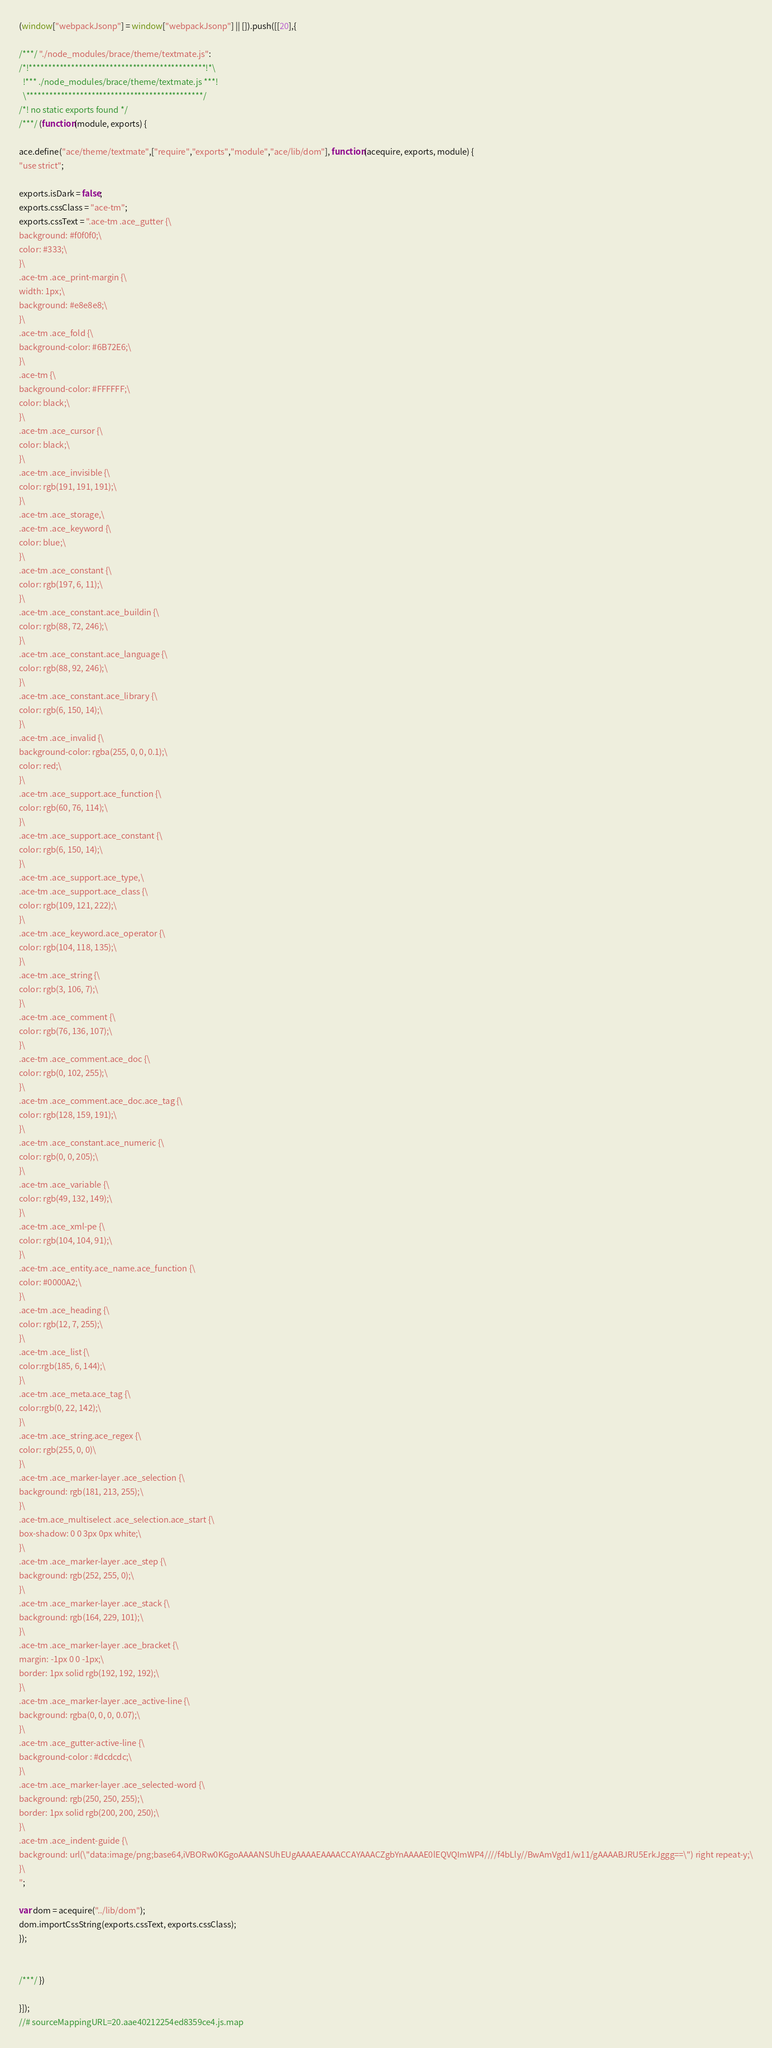Convert code to text. <code><loc_0><loc_0><loc_500><loc_500><_JavaScript_>(window["webpackJsonp"] = window["webpackJsonp"] || []).push([[20],{

/***/ "./node_modules/brace/theme/textmate.js":
/*!**********************************************!*\
  !*** ./node_modules/brace/theme/textmate.js ***!
  \**********************************************/
/*! no static exports found */
/***/ (function(module, exports) {

ace.define("ace/theme/textmate",["require","exports","module","ace/lib/dom"], function(acequire, exports, module) {
"use strict";

exports.isDark = false;
exports.cssClass = "ace-tm";
exports.cssText = ".ace-tm .ace_gutter {\
background: #f0f0f0;\
color: #333;\
}\
.ace-tm .ace_print-margin {\
width: 1px;\
background: #e8e8e8;\
}\
.ace-tm .ace_fold {\
background-color: #6B72E6;\
}\
.ace-tm {\
background-color: #FFFFFF;\
color: black;\
}\
.ace-tm .ace_cursor {\
color: black;\
}\
.ace-tm .ace_invisible {\
color: rgb(191, 191, 191);\
}\
.ace-tm .ace_storage,\
.ace-tm .ace_keyword {\
color: blue;\
}\
.ace-tm .ace_constant {\
color: rgb(197, 6, 11);\
}\
.ace-tm .ace_constant.ace_buildin {\
color: rgb(88, 72, 246);\
}\
.ace-tm .ace_constant.ace_language {\
color: rgb(88, 92, 246);\
}\
.ace-tm .ace_constant.ace_library {\
color: rgb(6, 150, 14);\
}\
.ace-tm .ace_invalid {\
background-color: rgba(255, 0, 0, 0.1);\
color: red;\
}\
.ace-tm .ace_support.ace_function {\
color: rgb(60, 76, 114);\
}\
.ace-tm .ace_support.ace_constant {\
color: rgb(6, 150, 14);\
}\
.ace-tm .ace_support.ace_type,\
.ace-tm .ace_support.ace_class {\
color: rgb(109, 121, 222);\
}\
.ace-tm .ace_keyword.ace_operator {\
color: rgb(104, 118, 135);\
}\
.ace-tm .ace_string {\
color: rgb(3, 106, 7);\
}\
.ace-tm .ace_comment {\
color: rgb(76, 136, 107);\
}\
.ace-tm .ace_comment.ace_doc {\
color: rgb(0, 102, 255);\
}\
.ace-tm .ace_comment.ace_doc.ace_tag {\
color: rgb(128, 159, 191);\
}\
.ace-tm .ace_constant.ace_numeric {\
color: rgb(0, 0, 205);\
}\
.ace-tm .ace_variable {\
color: rgb(49, 132, 149);\
}\
.ace-tm .ace_xml-pe {\
color: rgb(104, 104, 91);\
}\
.ace-tm .ace_entity.ace_name.ace_function {\
color: #0000A2;\
}\
.ace-tm .ace_heading {\
color: rgb(12, 7, 255);\
}\
.ace-tm .ace_list {\
color:rgb(185, 6, 144);\
}\
.ace-tm .ace_meta.ace_tag {\
color:rgb(0, 22, 142);\
}\
.ace-tm .ace_string.ace_regex {\
color: rgb(255, 0, 0)\
}\
.ace-tm .ace_marker-layer .ace_selection {\
background: rgb(181, 213, 255);\
}\
.ace-tm.ace_multiselect .ace_selection.ace_start {\
box-shadow: 0 0 3px 0px white;\
}\
.ace-tm .ace_marker-layer .ace_step {\
background: rgb(252, 255, 0);\
}\
.ace-tm .ace_marker-layer .ace_stack {\
background: rgb(164, 229, 101);\
}\
.ace-tm .ace_marker-layer .ace_bracket {\
margin: -1px 0 0 -1px;\
border: 1px solid rgb(192, 192, 192);\
}\
.ace-tm .ace_marker-layer .ace_active-line {\
background: rgba(0, 0, 0, 0.07);\
}\
.ace-tm .ace_gutter-active-line {\
background-color : #dcdcdc;\
}\
.ace-tm .ace_marker-layer .ace_selected-word {\
background: rgb(250, 250, 255);\
border: 1px solid rgb(200, 200, 250);\
}\
.ace-tm .ace_indent-guide {\
background: url(\"data:image/png;base64,iVBORw0KGgoAAAANSUhEUgAAAAEAAAACCAYAAACZgbYnAAAAE0lEQVQImWP4////f4bLly//BwAmVgd1/w11/gAAAABJRU5ErkJggg==\") right repeat-y;\
}\
";

var dom = acequire("../lib/dom");
dom.importCssString(exports.cssText, exports.cssClass);
});


/***/ })

}]);
//# sourceMappingURL=20.aae40212254ed8359ce4.js.map</code> 